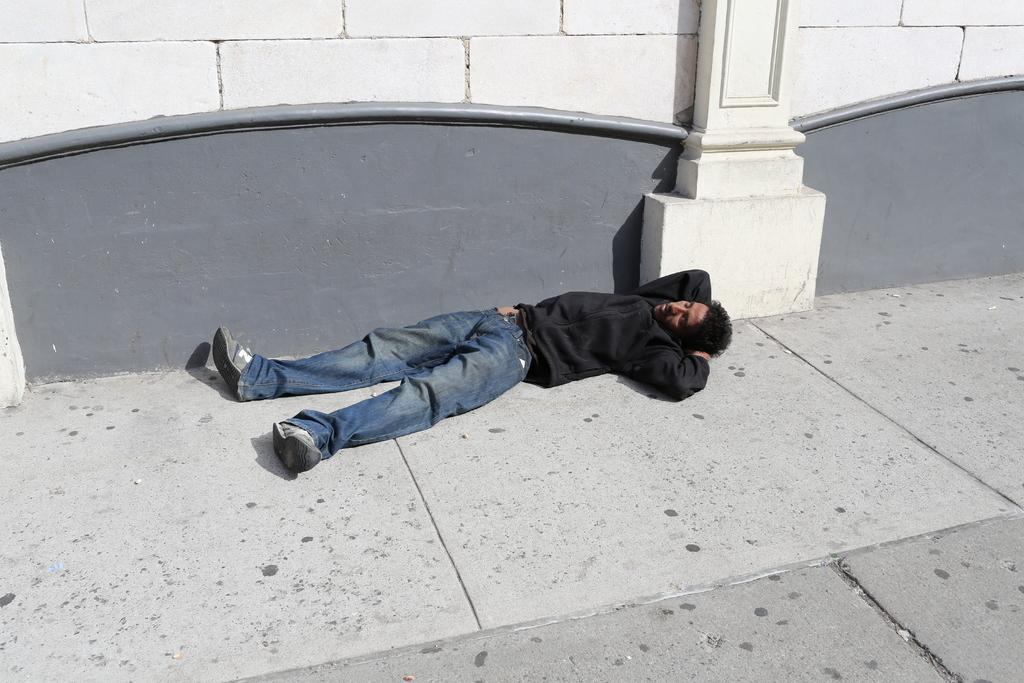What is the man in the image doing? The man is lying on the path in the image. What can be seen in the background of the image? There is a wall and a pillar in the background of the image. What type of pear is the man holding in the image? There is no pear present in the image; the man is lying on the path. What is the man using to serve food on the plate in the image? There is no plate or food present in the image. 